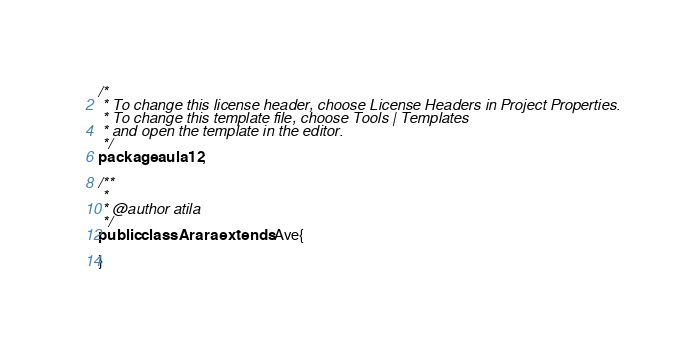<code> <loc_0><loc_0><loc_500><loc_500><_Java_>/*
 * To change this license header, choose License Headers in Project Properties.
 * To change this template file, choose Tools | Templates
 * and open the template in the editor.
 */
package aula12;

/**
 *
 * @author atila
 */
public class Arara extends Ave{
    
}
</code> 